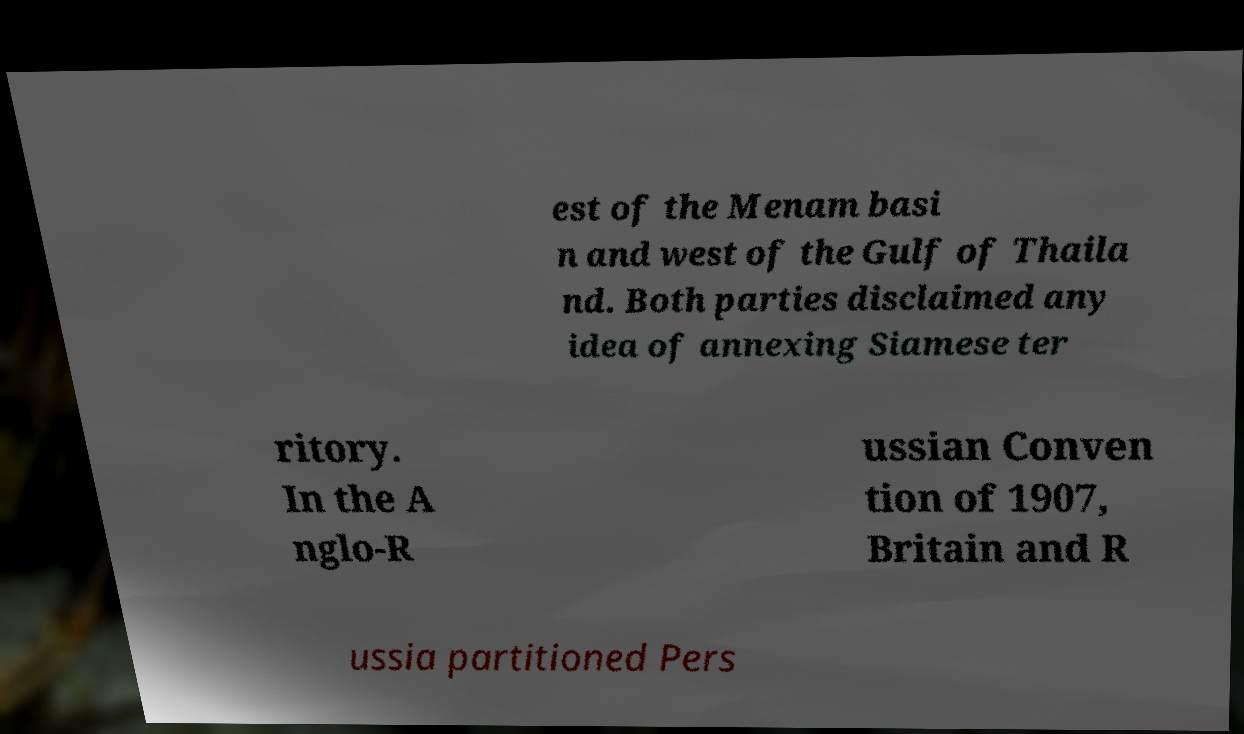Can you read and provide the text displayed in the image?This photo seems to have some interesting text. Can you extract and type it out for me? est of the Menam basi n and west of the Gulf of Thaila nd. Both parties disclaimed any idea of annexing Siamese ter ritory. In the A nglo-R ussian Conven tion of 1907, Britain and R ussia partitioned Pers 